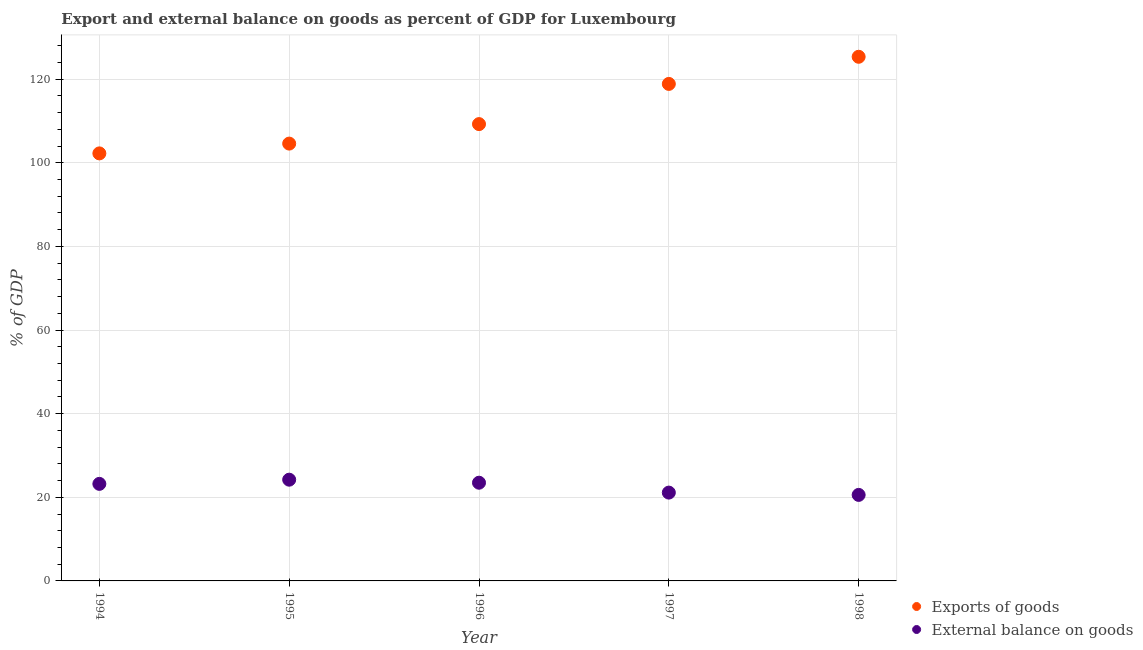How many different coloured dotlines are there?
Ensure brevity in your answer.  2. Is the number of dotlines equal to the number of legend labels?
Offer a terse response. Yes. What is the export of goods as percentage of gdp in 1994?
Your response must be concise. 102.25. Across all years, what is the maximum external balance on goods as percentage of gdp?
Provide a succinct answer. 24.21. Across all years, what is the minimum external balance on goods as percentage of gdp?
Offer a terse response. 20.57. In which year was the export of goods as percentage of gdp minimum?
Provide a short and direct response. 1994. What is the total external balance on goods as percentage of gdp in the graph?
Provide a short and direct response. 112.61. What is the difference between the export of goods as percentage of gdp in 1995 and that in 1997?
Make the answer very short. -14.27. What is the difference between the export of goods as percentage of gdp in 1998 and the external balance on goods as percentage of gdp in 1996?
Ensure brevity in your answer.  101.87. What is the average external balance on goods as percentage of gdp per year?
Make the answer very short. 22.52. In the year 1997, what is the difference between the external balance on goods as percentage of gdp and export of goods as percentage of gdp?
Provide a succinct answer. -97.75. What is the ratio of the external balance on goods as percentage of gdp in 1996 to that in 1997?
Offer a terse response. 1.11. Is the external balance on goods as percentage of gdp in 1996 less than that in 1998?
Offer a terse response. No. What is the difference between the highest and the second highest external balance on goods as percentage of gdp?
Ensure brevity in your answer.  0.72. What is the difference between the highest and the lowest export of goods as percentage of gdp?
Offer a terse response. 23.11. Is the external balance on goods as percentage of gdp strictly greater than the export of goods as percentage of gdp over the years?
Make the answer very short. No. How many dotlines are there?
Ensure brevity in your answer.  2. How many years are there in the graph?
Provide a short and direct response. 5. Does the graph contain any zero values?
Make the answer very short. No. Does the graph contain grids?
Ensure brevity in your answer.  Yes. Where does the legend appear in the graph?
Make the answer very short. Bottom right. How are the legend labels stacked?
Your response must be concise. Vertical. What is the title of the graph?
Ensure brevity in your answer.  Export and external balance on goods as percent of GDP for Luxembourg. Does "Total Population" appear as one of the legend labels in the graph?
Provide a succinct answer. No. What is the label or title of the Y-axis?
Your answer should be compact. % of GDP. What is the % of GDP of Exports of goods in 1994?
Your answer should be very brief. 102.25. What is the % of GDP in External balance on goods in 1994?
Make the answer very short. 23.21. What is the % of GDP of Exports of goods in 1995?
Make the answer very short. 104.6. What is the % of GDP of External balance on goods in 1995?
Offer a very short reply. 24.21. What is the % of GDP of Exports of goods in 1996?
Keep it short and to the point. 109.26. What is the % of GDP of External balance on goods in 1996?
Provide a succinct answer. 23.49. What is the % of GDP of Exports of goods in 1997?
Your response must be concise. 118.87. What is the % of GDP in External balance on goods in 1997?
Your answer should be compact. 21.12. What is the % of GDP in Exports of goods in 1998?
Your answer should be very brief. 125.36. What is the % of GDP in External balance on goods in 1998?
Your response must be concise. 20.57. Across all years, what is the maximum % of GDP of Exports of goods?
Make the answer very short. 125.36. Across all years, what is the maximum % of GDP of External balance on goods?
Your response must be concise. 24.21. Across all years, what is the minimum % of GDP in Exports of goods?
Keep it short and to the point. 102.25. Across all years, what is the minimum % of GDP in External balance on goods?
Provide a short and direct response. 20.57. What is the total % of GDP in Exports of goods in the graph?
Provide a short and direct response. 560.34. What is the total % of GDP in External balance on goods in the graph?
Make the answer very short. 112.61. What is the difference between the % of GDP of Exports of goods in 1994 and that in 1995?
Provide a succinct answer. -2.34. What is the difference between the % of GDP in External balance on goods in 1994 and that in 1995?
Your answer should be very brief. -1. What is the difference between the % of GDP in Exports of goods in 1994 and that in 1996?
Give a very brief answer. -7.01. What is the difference between the % of GDP in External balance on goods in 1994 and that in 1996?
Offer a terse response. -0.28. What is the difference between the % of GDP of Exports of goods in 1994 and that in 1997?
Keep it short and to the point. -16.62. What is the difference between the % of GDP in External balance on goods in 1994 and that in 1997?
Offer a terse response. 2.09. What is the difference between the % of GDP of Exports of goods in 1994 and that in 1998?
Provide a short and direct response. -23.11. What is the difference between the % of GDP in External balance on goods in 1994 and that in 1998?
Your response must be concise. 2.64. What is the difference between the % of GDP in Exports of goods in 1995 and that in 1996?
Provide a succinct answer. -4.66. What is the difference between the % of GDP in External balance on goods in 1995 and that in 1996?
Offer a very short reply. 0.72. What is the difference between the % of GDP in Exports of goods in 1995 and that in 1997?
Ensure brevity in your answer.  -14.27. What is the difference between the % of GDP of External balance on goods in 1995 and that in 1997?
Give a very brief answer. 3.09. What is the difference between the % of GDP in Exports of goods in 1995 and that in 1998?
Offer a very short reply. -20.76. What is the difference between the % of GDP in External balance on goods in 1995 and that in 1998?
Provide a succinct answer. 3.64. What is the difference between the % of GDP in Exports of goods in 1996 and that in 1997?
Offer a terse response. -9.61. What is the difference between the % of GDP of External balance on goods in 1996 and that in 1997?
Give a very brief answer. 2.36. What is the difference between the % of GDP of Exports of goods in 1996 and that in 1998?
Make the answer very short. -16.1. What is the difference between the % of GDP of External balance on goods in 1996 and that in 1998?
Provide a succinct answer. 2.92. What is the difference between the % of GDP in Exports of goods in 1997 and that in 1998?
Ensure brevity in your answer.  -6.49. What is the difference between the % of GDP of External balance on goods in 1997 and that in 1998?
Provide a short and direct response. 0.55. What is the difference between the % of GDP in Exports of goods in 1994 and the % of GDP in External balance on goods in 1995?
Make the answer very short. 78.04. What is the difference between the % of GDP of Exports of goods in 1994 and the % of GDP of External balance on goods in 1996?
Keep it short and to the point. 78.77. What is the difference between the % of GDP of Exports of goods in 1994 and the % of GDP of External balance on goods in 1997?
Give a very brief answer. 81.13. What is the difference between the % of GDP of Exports of goods in 1994 and the % of GDP of External balance on goods in 1998?
Provide a short and direct response. 81.68. What is the difference between the % of GDP in Exports of goods in 1995 and the % of GDP in External balance on goods in 1996?
Your response must be concise. 81.11. What is the difference between the % of GDP of Exports of goods in 1995 and the % of GDP of External balance on goods in 1997?
Your response must be concise. 83.47. What is the difference between the % of GDP of Exports of goods in 1995 and the % of GDP of External balance on goods in 1998?
Offer a very short reply. 84.02. What is the difference between the % of GDP in Exports of goods in 1996 and the % of GDP in External balance on goods in 1997?
Offer a very short reply. 88.14. What is the difference between the % of GDP of Exports of goods in 1996 and the % of GDP of External balance on goods in 1998?
Provide a short and direct response. 88.69. What is the difference between the % of GDP of Exports of goods in 1997 and the % of GDP of External balance on goods in 1998?
Ensure brevity in your answer.  98.3. What is the average % of GDP in Exports of goods per year?
Your answer should be compact. 112.07. What is the average % of GDP of External balance on goods per year?
Give a very brief answer. 22.52. In the year 1994, what is the difference between the % of GDP of Exports of goods and % of GDP of External balance on goods?
Your response must be concise. 79.04. In the year 1995, what is the difference between the % of GDP of Exports of goods and % of GDP of External balance on goods?
Your response must be concise. 80.38. In the year 1996, what is the difference between the % of GDP of Exports of goods and % of GDP of External balance on goods?
Provide a short and direct response. 85.77. In the year 1997, what is the difference between the % of GDP in Exports of goods and % of GDP in External balance on goods?
Provide a succinct answer. 97.75. In the year 1998, what is the difference between the % of GDP in Exports of goods and % of GDP in External balance on goods?
Offer a very short reply. 104.79. What is the ratio of the % of GDP in Exports of goods in 1994 to that in 1995?
Your answer should be compact. 0.98. What is the ratio of the % of GDP of External balance on goods in 1994 to that in 1995?
Keep it short and to the point. 0.96. What is the ratio of the % of GDP in Exports of goods in 1994 to that in 1996?
Your answer should be very brief. 0.94. What is the ratio of the % of GDP in External balance on goods in 1994 to that in 1996?
Provide a succinct answer. 0.99. What is the ratio of the % of GDP of Exports of goods in 1994 to that in 1997?
Your response must be concise. 0.86. What is the ratio of the % of GDP in External balance on goods in 1994 to that in 1997?
Your response must be concise. 1.1. What is the ratio of the % of GDP of Exports of goods in 1994 to that in 1998?
Ensure brevity in your answer.  0.82. What is the ratio of the % of GDP of External balance on goods in 1994 to that in 1998?
Your answer should be very brief. 1.13. What is the ratio of the % of GDP of Exports of goods in 1995 to that in 1996?
Provide a short and direct response. 0.96. What is the ratio of the % of GDP of External balance on goods in 1995 to that in 1996?
Offer a terse response. 1.03. What is the ratio of the % of GDP of Exports of goods in 1995 to that in 1997?
Provide a short and direct response. 0.88. What is the ratio of the % of GDP in External balance on goods in 1995 to that in 1997?
Ensure brevity in your answer.  1.15. What is the ratio of the % of GDP of Exports of goods in 1995 to that in 1998?
Offer a terse response. 0.83. What is the ratio of the % of GDP of External balance on goods in 1995 to that in 1998?
Keep it short and to the point. 1.18. What is the ratio of the % of GDP in Exports of goods in 1996 to that in 1997?
Your answer should be very brief. 0.92. What is the ratio of the % of GDP of External balance on goods in 1996 to that in 1997?
Your answer should be compact. 1.11. What is the ratio of the % of GDP of Exports of goods in 1996 to that in 1998?
Provide a succinct answer. 0.87. What is the ratio of the % of GDP in External balance on goods in 1996 to that in 1998?
Provide a succinct answer. 1.14. What is the ratio of the % of GDP of Exports of goods in 1997 to that in 1998?
Offer a very short reply. 0.95. What is the ratio of the % of GDP of External balance on goods in 1997 to that in 1998?
Keep it short and to the point. 1.03. What is the difference between the highest and the second highest % of GDP of Exports of goods?
Your response must be concise. 6.49. What is the difference between the highest and the second highest % of GDP of External balance on goods?
Make the answer very short. 0.72. What is the difference between the highest and the lowest % of GDP in Exports of goods?
Offer a terse response. 23.11. What is the difference between the highest and the lowest % of GDP in External balance on goods?
Your answer should be very brief. 3.64. 